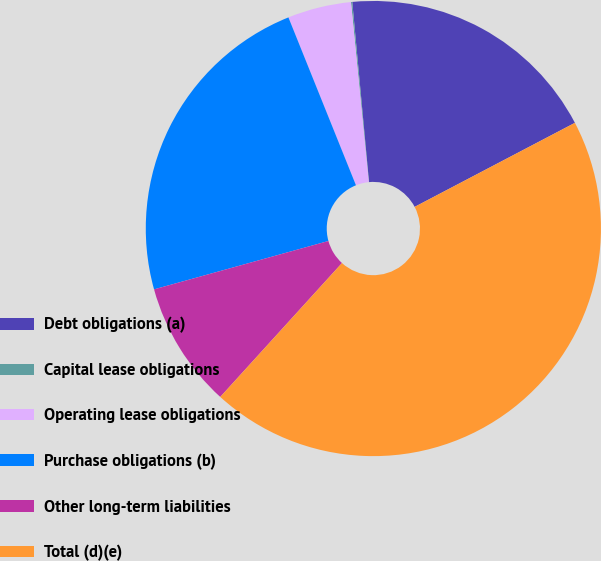<chart> <loc_0><loc_0><loc_500><loc_500><pie_chart><fcel>Debt obligations (a)<fcel>Capital lease obligations<fcel>Operating lease obligations<fcel>Purchase obligations (b)<fcel>Other long-term liabilities<fcel>Total (d)(e)<nl><fcel>18.79%<fcel>0.09%<fcel>4.52%<fcel>23.22%<fcel>8.95%<fcel>44.43%<nl></chart> 